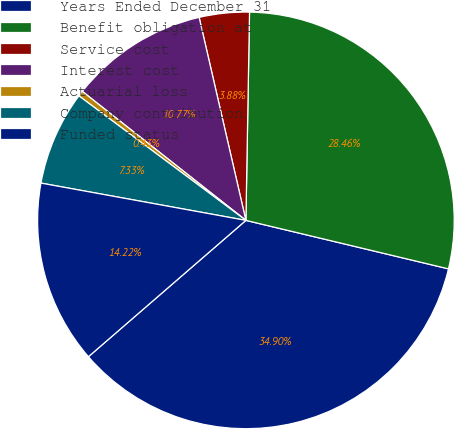Convert chart to OTSL. <chart><loc_0><loc_0><loc_500><loc_500><pie_chart><fcel>Years Ended December 31<fcel>Benefit obligation at<fcel>Service cost<fcel>Interest cost<fcel>Actuarial loss<fcel>Company contribution<fcel>Funded status<nl><fcel>34.9%<fcel>28.46%<fcel>3.88%<fcel>10.77%<fcel>0.43%<fcel>7.33%<fcel>14.22%<nl></chart> 